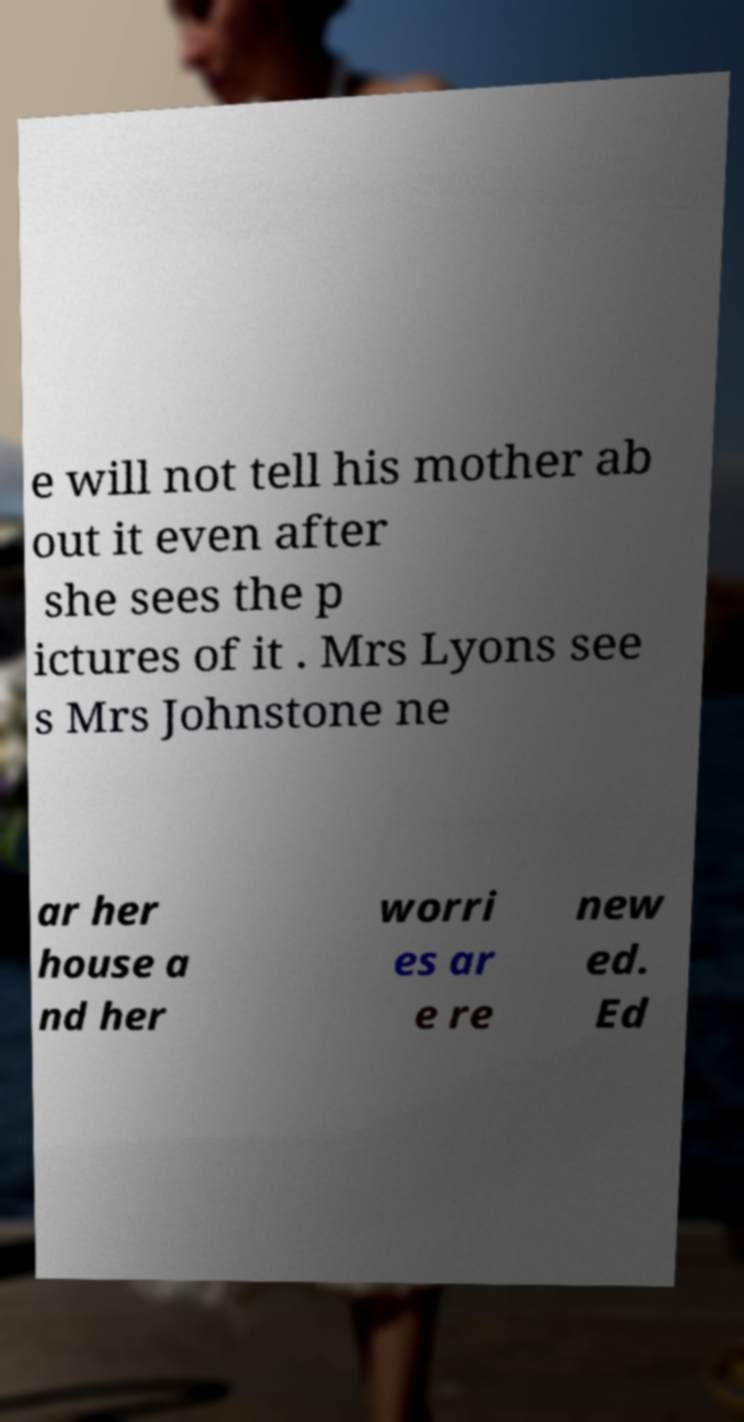Please identify and transcribe the text found in this image. e will not tell his mother ab out it even after she sees the p ictures of it . Mrs Lyons see s Mrs Johnstone ne ar her house a nd her worri es ar e re new ed. Ed 